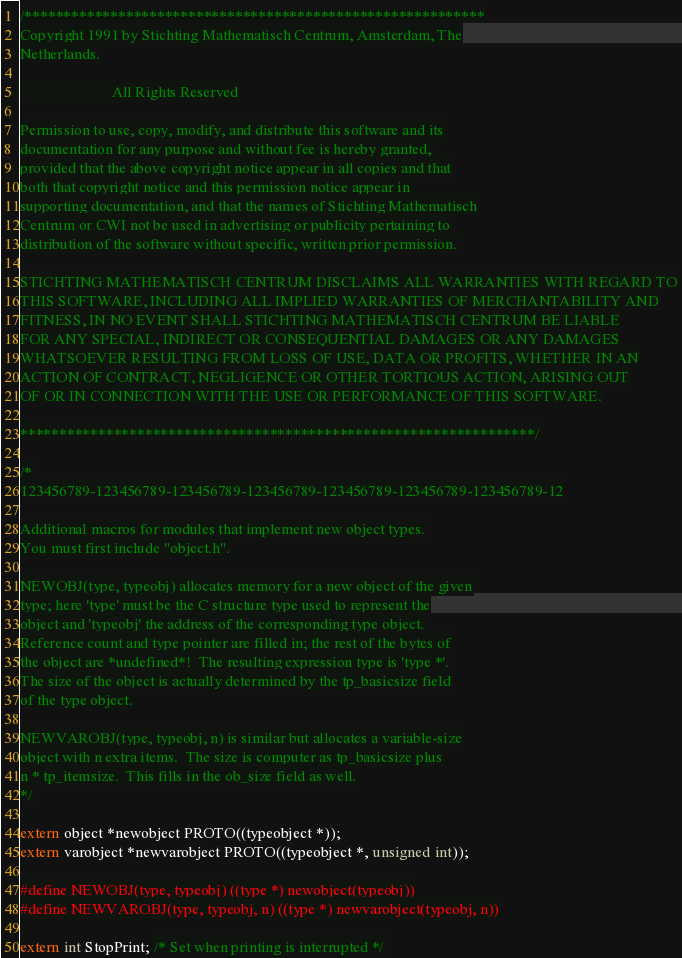<code> <loc_0><loc_0><loc_500><loc_500><_C_>/***********************************************************
Copyright 1991 by Stichting Mathematisch Centrum, Amsterdam, The
Netherlands.

                        All Rights Reserved

Permission to use, copy, modify, and distribute this software and its 
documentation for any purpose and without fee is hereby granted, 
provided that the above copyright notice appear in all copies and that
both that copyright notice and this permission notice appear in 
supporting documentation, and that the names of Stichting Mathematisch
Centrum or CWI not be used in advertising or publicity pertaining to
distribution of the software without specific, written prior permission.

STICHTING MATHEMATISCH CENTRUM DISCLAIMS ALL WARRANTIES WITH REGARD TO
THIS SOFTWARE, INCLUDING ALL IMPLIED WARRANTIES OF MERCHANTABILITY AND
FITNESS, IN NO EVENT SHALL STICHTING MATHEMATISCH CENTRUM BE LIABLE
FOR ANY SPECIAL, INDIRECT OR CONSEQUENTIAL DAMAGES OR ANY DAMAGES
WHATSOEVER RESULTING FROM LOSS OF USE, DATA OR PROFITS, WHETHER IN AN
ACTION OF CONTRACT, NEGLIGENCE OR OTHER TORTIOUS ACTION, ARISING OUT
OF OR IN CONNECTION WITH THE USE OR PERFORMANCE OF THIS SOFTWARE.

******************************************************************/

/*
123456789-123456789-123456789-123456789-123456789-123456789-123456789-12

Additional macros for modules that implement new object types.
You must first include "object.h".

NEWOBJ(type, typeobj) allocates memory for a new object of the given
type; here 'type' must be the C structure type used to represent the
object and 'typeobj' the address of the corresponding type object.
Reference count and type pointer are filled in; the rest of the bytes of
the object are *undefined*!  The resulting expression type is 'type *'.
The size of the object is actually determined by the tp_basicsize field
of the type object.

NEWVAROBJ(type, typeobj, n) is similar but allocates a variable-size
object with n extra items.  The size is computer as tp_basicsize plus
n * tp_itemsize.  This fills in the ob_size field as well.
*/

extern object *newobject PROTO((typeobject *));
extern varobject *newvarobject PROTO((typeobject *, unsigned int));

#define NEWOBJ(type, typeobj) ((type *) newobject(typeobj))
#define NEWVAROBJ(type, typeobj, n) ((type *) newvarobject(typeobj, n))

extern int StopPrint; /* Set when printing is interrupted */
</code> 